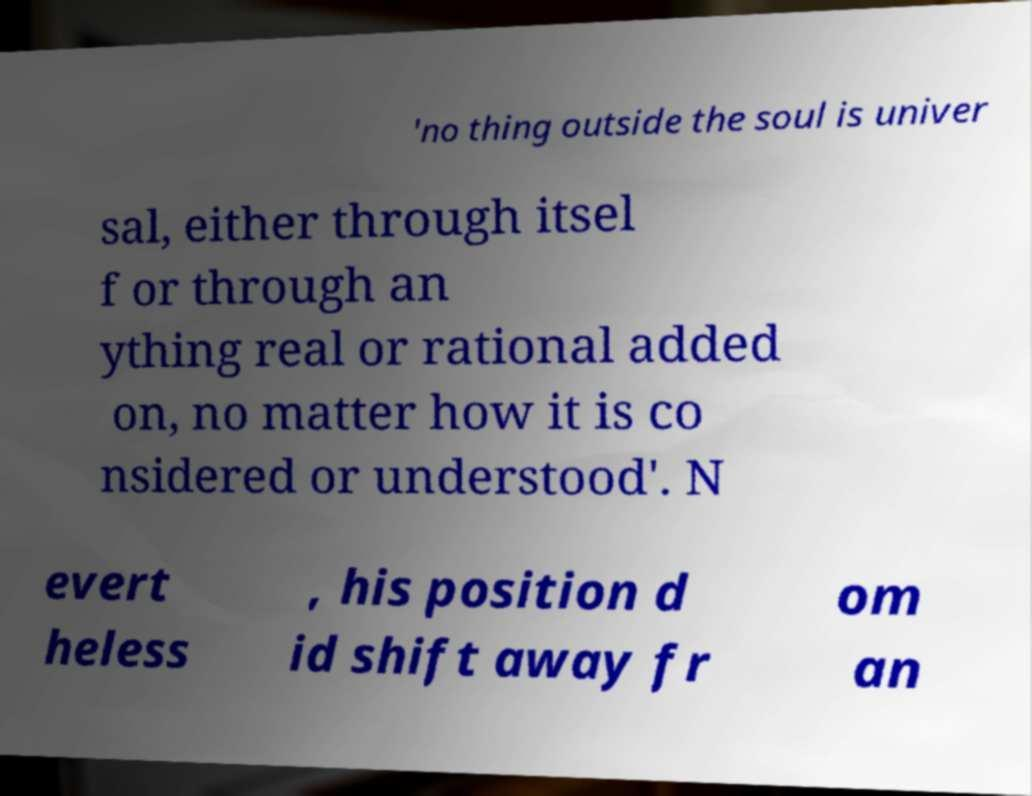Can you accurately transcribe the text from the provided image for me? 'no thing outside the soul is univer sal, either through itsel f or through an ything real or rational added on, no matter how it is co nsidered or understood'. N evert heless , his position d id shift away fr om an 